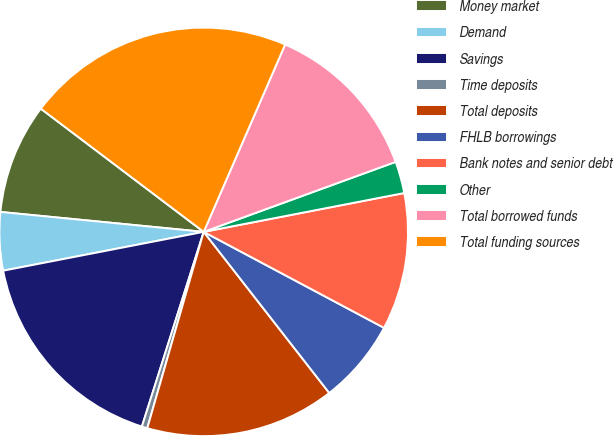Convert chart. <chart><loc_0><loc_0><loc_500><loc_500><pie_chart><fcel>Money market<fcel>Demand<fcel>Savings<fcel>Time deposits<fcel>Total deposits<fcel>FHLB borrowings<fcel>Bank notes and senior debt<fcel>Other<fcel>Total borrowed funds<fcel>Total funding sources<nl><fcel>8.75%<fcel>4.6%<fcel>17.06%<fcel>0.44%<fcel>14.99%<fcel>6.68%<fcel>10.83%<fcel>2.52%<fcel>12.91%<fcel>21.22%<nl></chart> 